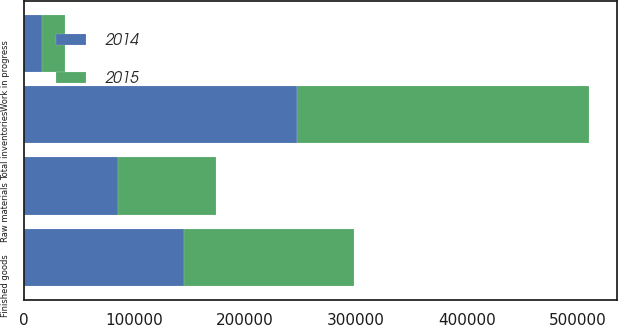Convert chart. <chart><loc_0><loc_0><loc_500><loc_500><stacked_bar_chart><ecel><fcel>Raw materials<fcel>Work in progress<fcel>Finished goods<fcel>Total inventories<nl><fcel>2015<fcel>88625<fcel>20901<fcel>153889<fcel>263415<nl><fcel>2014<fcel>84952<fcel>16749<fcel>144729<fcel>246430<nl></chart> 